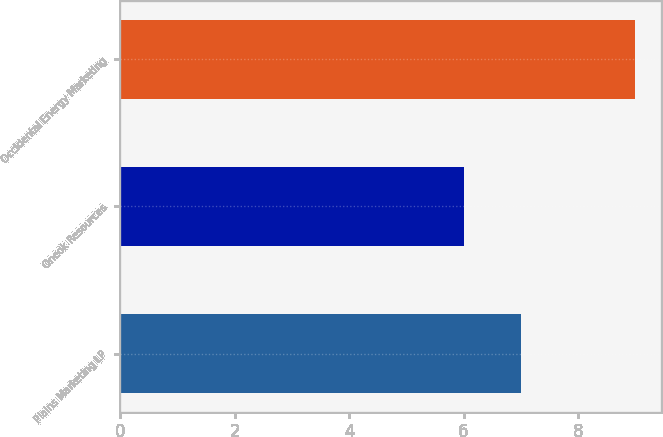Convert chart to OTSL. <chart><loc_0><loc_0><loc_500><loc_500><bar_chart><fcel>Plains Marketing LP<fcel>Oneok Resources<fcel>Occidental Energy Marketing<nl><fcel>7<fcel>6<fcel>9<nl></chart> 